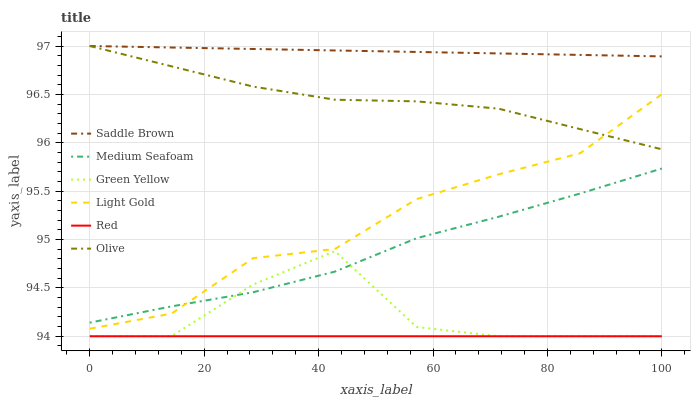Does Red have the minimum area under the curve?
Answer yes or no. Yes. Does Saddle Brown have the maximum area under the curve?
Answer yes or no. Yes. Does Olive have the minimum area under the curve?
Answer yes or no. No. Does Olive have the maximum area under the curve?
Answer yes or no. No. Is Red the smoothest?
Answer yes or no. Yes. Is Green Yellow the roughest?
Answer yes or no. Yes. Is Olive the smoothest?
Answer yes or no. No. Is Olive the roughest?
Answer yes or no. No. Does Green Yellow have the lowest value?
Answer yes or no. Yes. Does Olive have the lowest value?
Answer yes or no. No. Does Saddle Brown have the highest value?
Answer yes or no. Yes. Does Green Yellow have the highest value?
Answer yes or no. No. Is Red less than Light Gold?
Answer yes or no. Yes. Is Saddle Brown greater than Red?
Answer yes or no. Yes. Does Green Yellow intersect Red?
Answer yes or no. Yes. Is Green Yellow less than Red?
Answer yes or no. No. Is Green Yellow greater than Red?
Answer yes or no. No. Does Red intersect Light Gold?
Answer yes or no. No. 